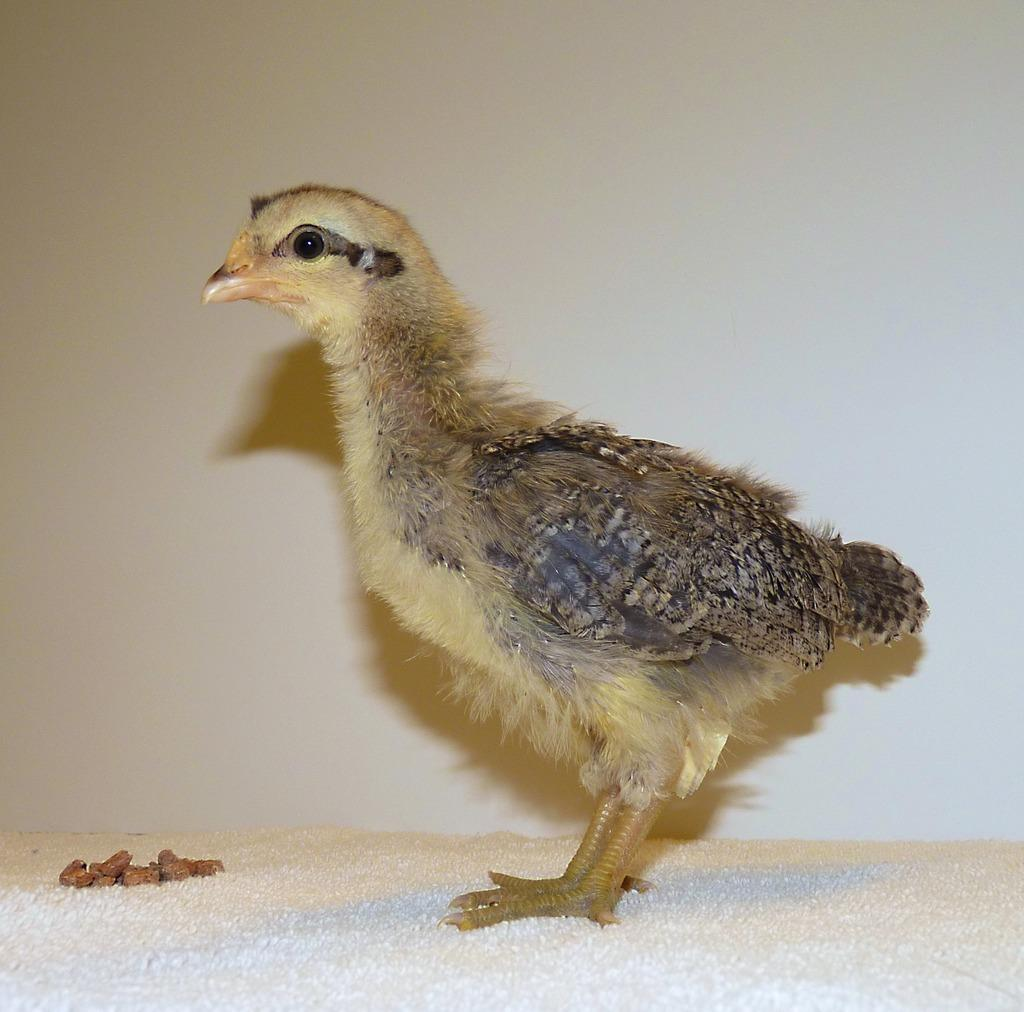What is located at the bottom of the image? There is a surface at the bottom of the image. What can be seen in the foreground of the image? There is a bird in the foreground of the image. What can be observed about the background of the image? The background of the image has a color. What language is the boy speaking in the image? There is no boy present in the image, only a bird. What type of bird is the boy holding in the image? There is no boy or bird holding in the image; it only features a bird in the foreground. 